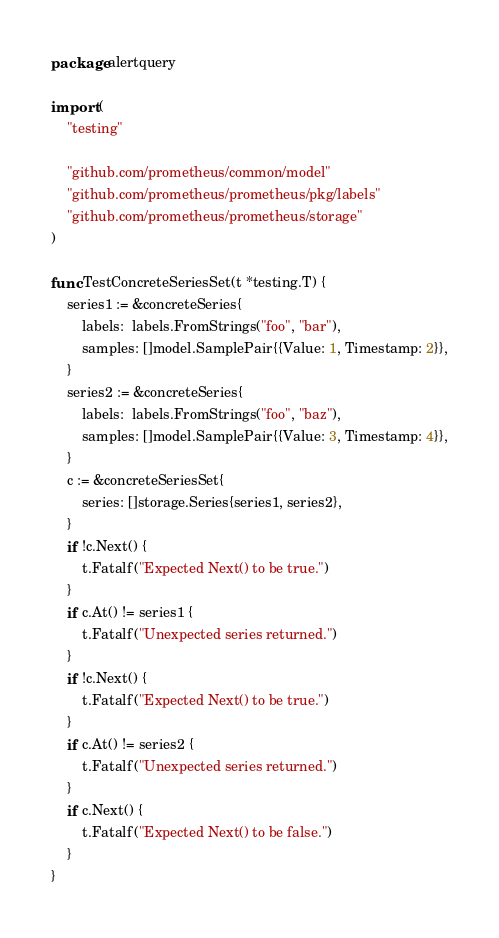Convert code to text. <code><loc_0><loc_0><loc_500><loc_500><_Go_>package alertquery

import (
	"testing"

	"github.com/prometheus/common/model"
	"github.com/prometheus/prometheus/pkg/labels"
	"github.com/prometheus/prometheus/storage"
)

func TestConcreteSeriesSet(t *testing.T) {
	series1 := &concreteSeries{
		labels:  labels.FromStrings("foo", "bar"),
		samples: []model.SamplePair{{Value: 1, Timestamp: 2}},
	}
	series2 := &concreteSeries{
		labels:  labels.FromStrings("foo", "baz"),
		samples: []model.SamplePair{{Value: 3, Timestamp: 4}},
	}
	c := &concreteSeriesSet{
		series: []storage.Series{series1, series2},
	}
	if !c.Next() {
		t.Fatalf("Expected Next() to be true.")
	}
	if c.At() != series1 {
		t.Fatalf("Unexpected series returned.")
	}
	if !c.Next() {
		t.Fatalf("Expected Next() to be true.")
	}
	if c.At() != series2 {
		t.Fatalf("Unexpected series returned.")
	}
	if c.Next() {
		t.Fatalf("Expected Next() to be false.")
	}
}
</code> 